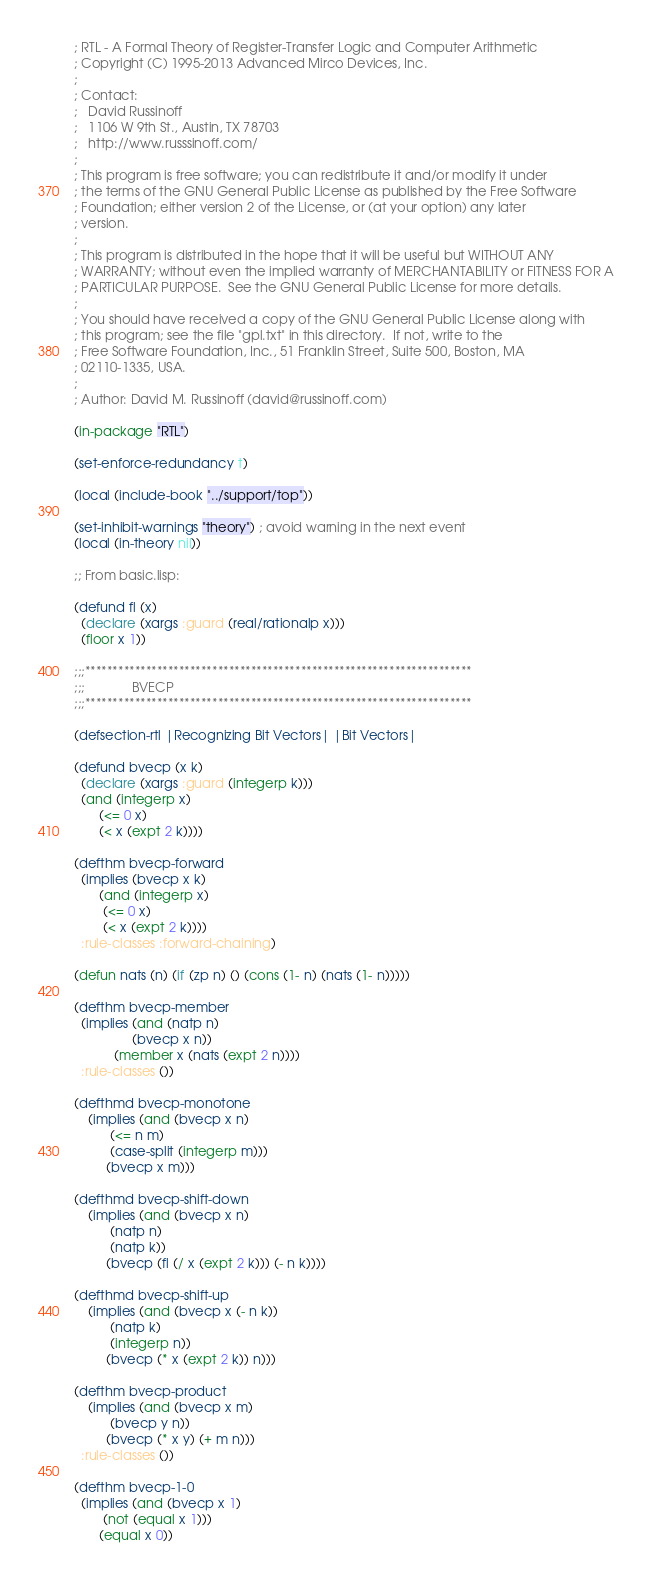<code> <loc_0><loc_0><loc_500><loc_500><_Lisp_>; RTL - A Formal Theory of Register-Transfer Logic and Computer Arithmetic 
; Copyright (C) 1995-2013 Advanced Mirco Devices, Inc. 
;
; Contact:
;   David Russinoff
;   1106 W 9th St., Austin, TX 78703
;   http://www.russsinoff.com/
;
; This program is free software; you can redistribute it and/or modify it under
; the terms of the GNU General Public License as published by the Free Software
; Foundation; either version 2 of the License, or (at your option) any later
; version.
;
; This program is distributed in the hope that it will be useful but WITHOUT ANY
; WARRANTY; without even the implied warranty of MERCHANTABILITY or FITNESS FOR A
; PARTICULAR PURPOSE.  See the GNU General Public License for more details.
;
; You should have received a copy of the GNU General Public License along with
; this program; see the file "gpl.txt" in this directory.  If not, write to the
; Free Software Foundation, Inc., 51 Franklin Street, Suite 500, Boston, MA
; 02110-1335, USA.
;
; Author: David M. Russinoff (david@russinoff.com)

(in-package "RTL")

(set-enforce-redundancy t)

(local (include-book "../support/top"))

(set-inhibit-warnings "theory") ; avoid warning in the next event
(local (in-theory nil))

;; From basic.lisp:

(defund fl (x)
  (declare (xargs :guard (real/rationalp x)))
  (floor x 1))

;;;**********************************************************************
;;;				BVECP
;;;**********************************************************************

(defsection-rtl |Recognizing Bit Vectors| |Bit Vectors|

(defund bvecp (x k)
  (declare (xargs :guard (integerp k)))
  (and (integerp x)
       (<= 0 x)
       (< x (expt 2 k))))

(defthm bvecp-forward
  (implies (bvecp x k)
	   (and (integerp x)
		(<= 0 x)
		(< x (expt 2 k))))
  :rule-classes :forward-chaining)

(defun nats (n) (if (zp n) () (cons (1- n) (nats (1- n)))))

(defthm bvecp-member
  (implies (and (natp n)
                (bvecp x n))
           (member x (nats (expt 2 n))))
  :rule-classes ())

(defthmd bvecp-monotone
    (implies (and (bvecp x n)
		  (<= n m)
		  (case-split (integerp m)))
	     (bvecp x m)))

(defthmd bvecp-shift-down
    (implies (and (bvecp x n)
		  (natp n)
		  (natp k))
	     (bvecp (fl (/ x (expt 2 k))) (- n k))))

(defthmd bvecp-shift-up
    (implies (and (bvecp x (- n k))
		  (natp k)
		  (integerp n))
	     (bvecp (* x (expt 2 k)) n)))

(defthm bvecp-product
    (implies (and (bvecp x m)
		  (bvecp y n))
	     (bvecp (* x y) (+ m n)))
  :rule-classes ())

(defthm bvecp-1-0
  (implies (and (bvecp x 1)
		(not (equal x 1)))
	   (equal x 0))</code> 